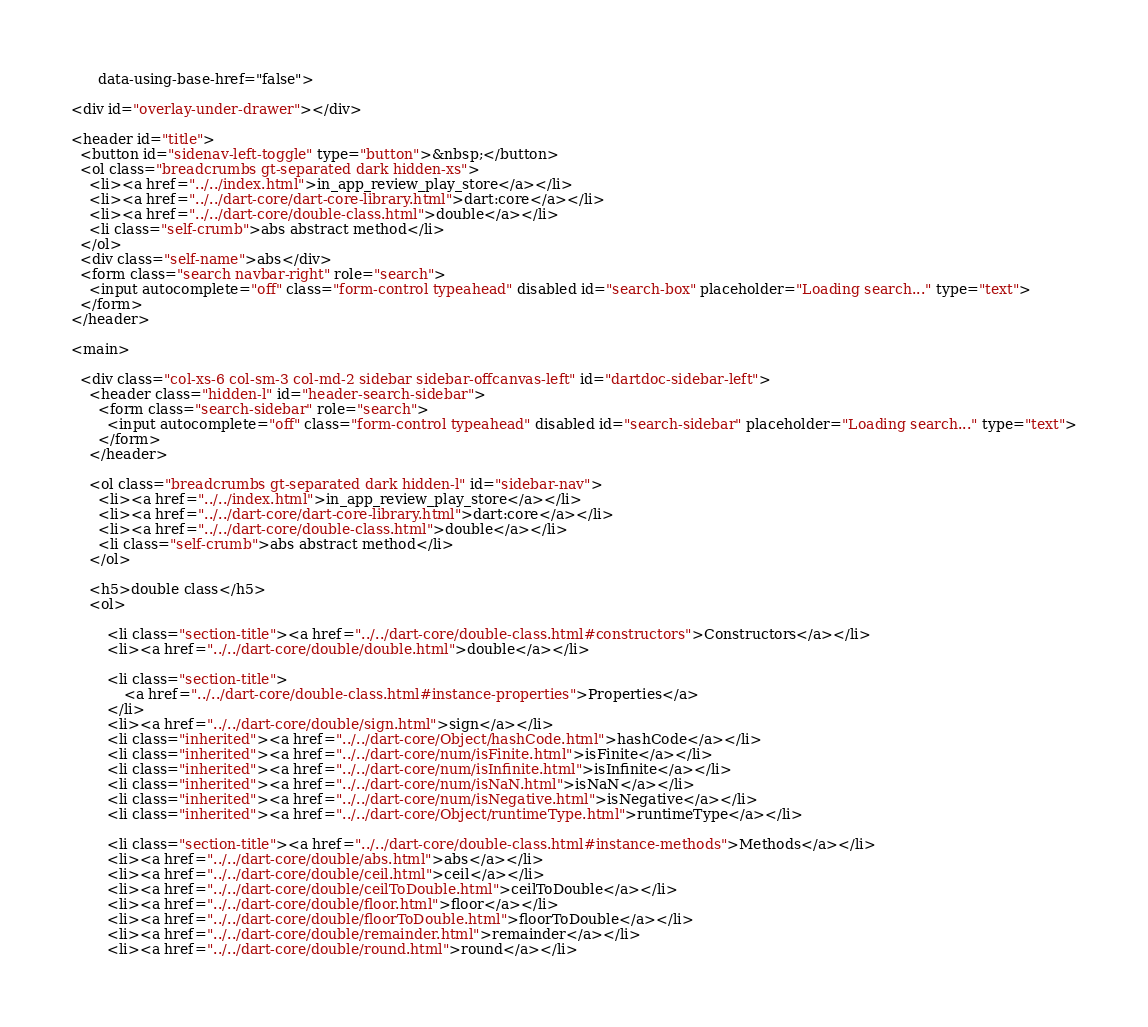Convert code to text. <code><loc_0><loc_0><loc_500><loc_500><_HTML_>      data-using-base-href="false">

<div id="overlay-under-drawer"></div>

<header id="title">
  <button id="sidenav-left-toggle" type="button">&nbsp;</button>
  <ol class="breadcrumbs gt-separated dark hidden-xs">
    <li><a href="../../index.html">in_app_review_play_store</a></li>
    <li><a href="../../dart-core/dart-core-library.html">dart:core</a></li>
    <li><a href="../../dart-core/double-class.html">double</a></li>
    <li class="self-crumb">abs abstract method</li>
  </ol>
  <div class="self-name">abs</div>
  <form class="search navbar-right" role="search">
    <input autocomplete="off" class="form-control typeahead" disabled id="search-box" placeholder="Loading search..." type="text">
  </form>
</header>

<main>

  <div class="col-xs-6 col-sm-3 col-md-2 sidebar sidebar-offcanvas-left" id="dartdoc-sidebar-left">
    <header class="hidden-l" id="header-search-sidebar">
      <form class="search-sidebar" role="search">
        <input autocomplete="off" class="form-control typeahead" disabled id="search-sidebar" placeholder="Loading search..." type="text">
      </form>
    </header>
    
    <ol class="breadcrumbs gt-separated dark hidden-l" id="sidebar-nav">
      <li><a href="../../index.html">in_app_review_play_store</a></li>
      <li><a href="../../dart-core/dart-core-library.html">dart:core</a></li>
      <li><a href="../../dart-core/double-class.html">double</a></li>
      <li class="self-crumb">abs abstract method</li>
    </ol>
    
    <h5>double class</h5>
    <ol>
    
        <li class="section-title"><a href="../../dart-core/double-class.html#constructors">Constructors</a></li>
        <li><a href="../../dart-core/double/double.html">double</a></li>
    
        <li class="section-title">
            <a href="../../dart-core/double-class.html#instance-properties">Properties</a>
        </li>
        <li><a href="../../dart-core/double/sign.html">sign</a></li>
        <li class="inherited"><a href="../../dart-core/Object/hashCode.html">hashCode</a></li>
        <li class="inherited"><a href="../../dart-core/num/isFinite.html">isFinite</a></li>
        <li class="inherited"><a href="../../dart-core/num/isInfinite.html">isInfinite</a></li>
        <li class="inherited"><a href="../../dart-core/num/isNaN.html">isNaN</a></li>
        <li class="inherited"><a href="../../dart-core/num/isNegative.html">isNegative</a></li>
        <li class="inherited"><a href="../../dart-core/Object/runtimeType.html">runtimeType</a></li>
    
        <li class="section-title"><a href="../../dart-core/double-class.html#instance-methods">Methods</a></li>
        <li><a href="../../dart-core/double/abs.html">abs</a></li>
        <li><a href="../../dart-core/double/ceil.html">ceil</a></li>
        <li><a href="../../dart-core/double/ceilToDouble.html">ceilToDouble</a></li>
        <li><a href="../../dart-core/double/floor.html">floor</a></li>
        <li><a href="../../dart-core/double/floorToDouble.html">floorToDouble</a></li>
        <li><a href="../../dart-core/double/remainder.html">remainder</a></li>
        <li><a href="../../dart-core/double/round.html">round</a></li></code> 